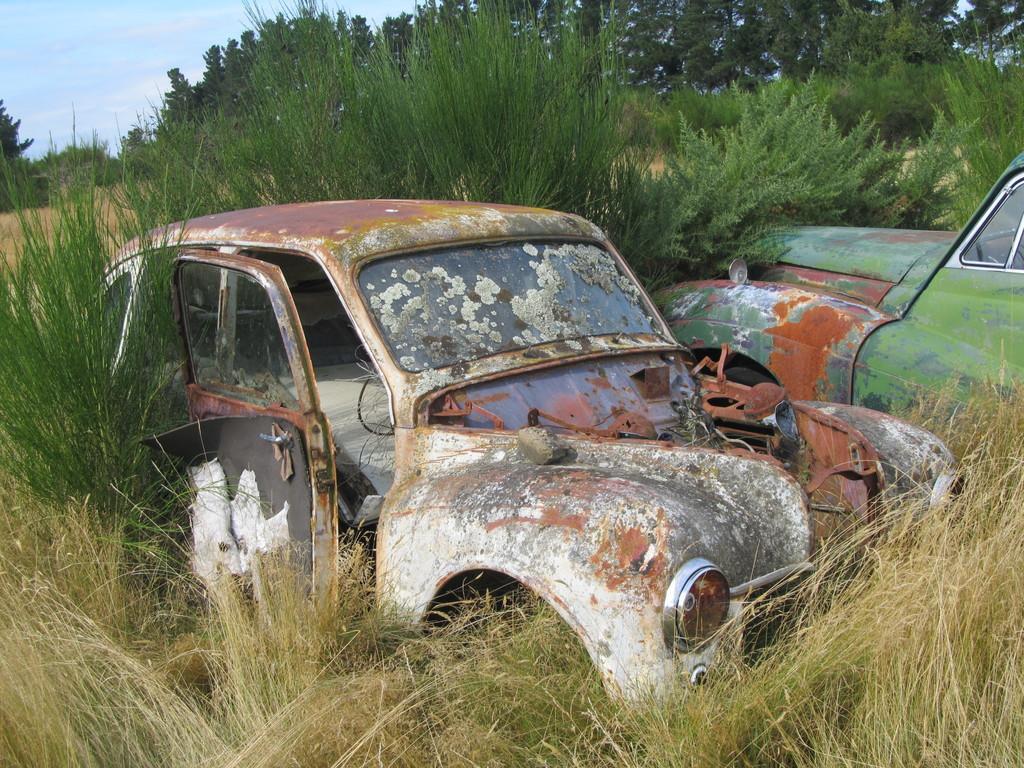Please provide a concise description of this image. We can see old vehicles on the grass. In the background we can see trees and sky. 